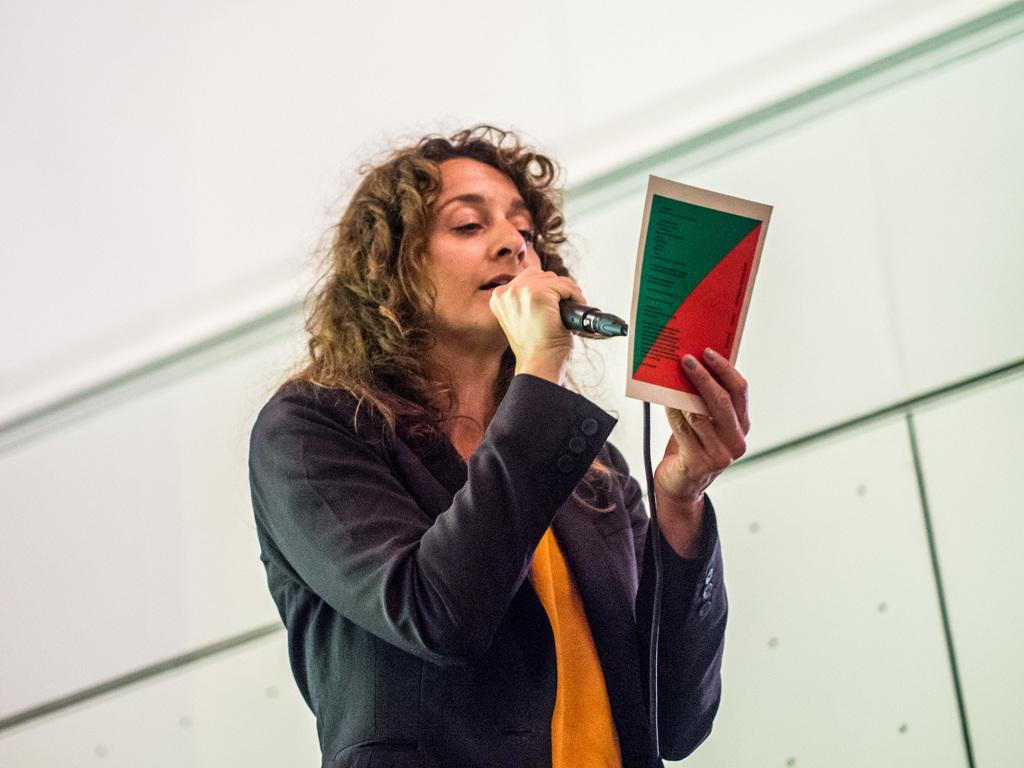What is the main subject of the image? There is a person standing in the center of the image. What is the person holding in their hands? The person is holding a mic and a paper. What can be seen in the background of the image? There is a wall in the background of the image. Is the person using a quill to write on the paper in the image? There is no quill present in the image, and the person is not shown writing on the paper. 